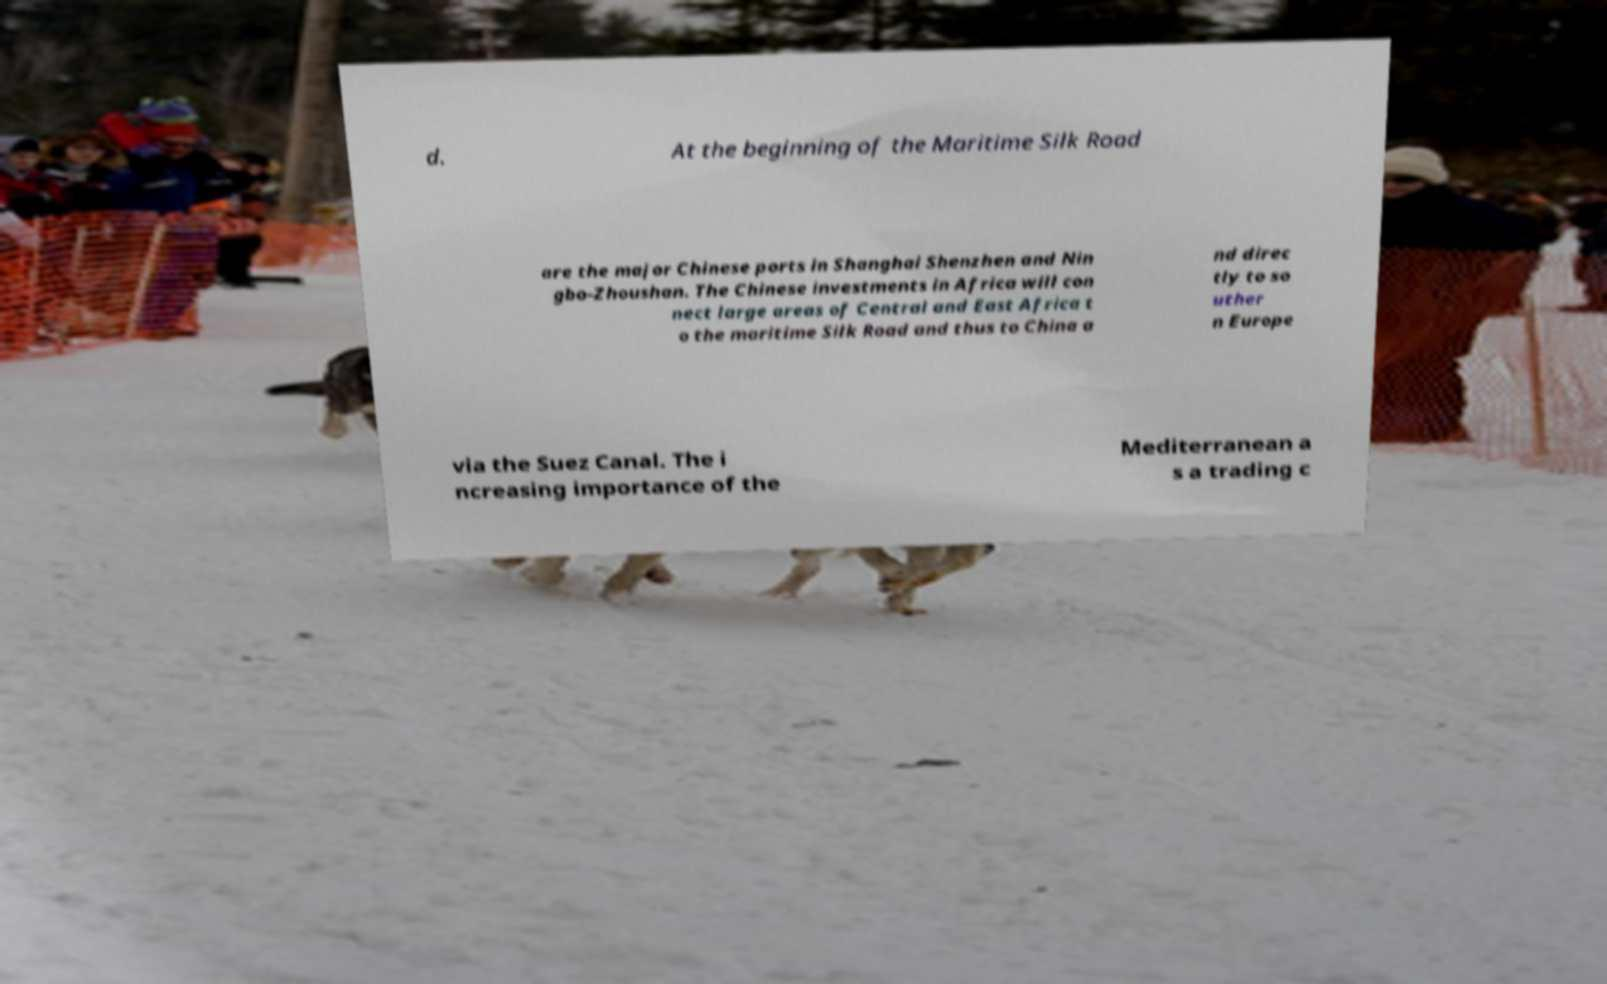Could you extract and type out the text from this image? d. At the beginning of the Maritime Silk Road are the major Chinese ports in Shanghai Shenzhen and Nin gbo-Zhoushan. The Chinese investments in Africa will con nect large areas of Central and East Africa t o the maritime Silk Road and thus to China a nd direc tly to so uther n Europe via the Suez Canal. The i ncreasing importance of the Mediterranean a s a trading c 